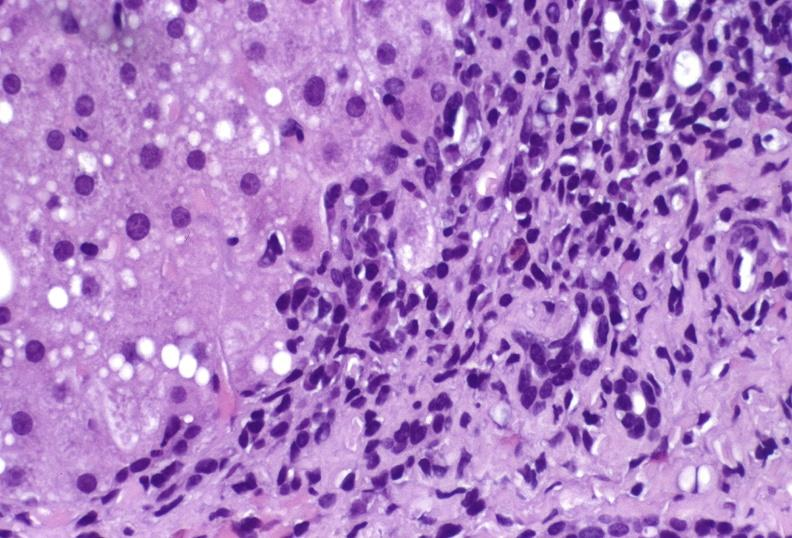what is present?
Answer the question using a single word or phrase. Liver 